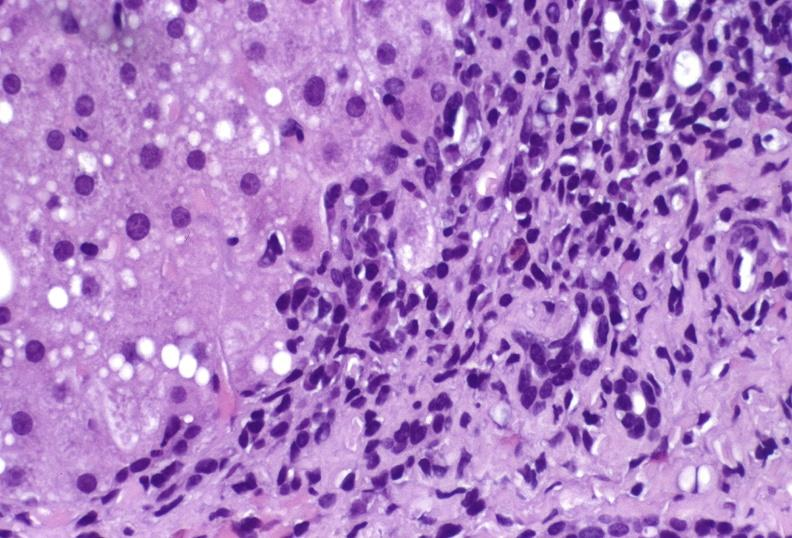what is present?
Answer the question using a single word or phrase. Liver 